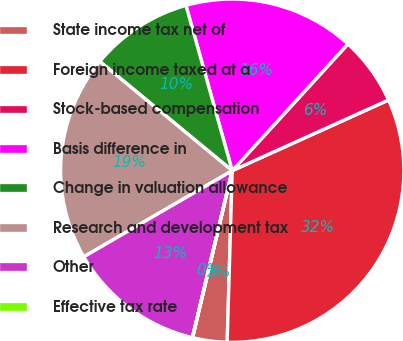Convert chart. <chart><loc_0><loc_0><loc_500><loc_500><pie_chart><fcel>State income tax net of<fcel>Foreign income taxed at a<fcel>Stock-based compensation<fcel>Basis difference in<fcel>Change in valuation allowance<fcel>Research and development tax<fcel>Other<fcel>Effective tax rate<nl><fcel>3.24%<fcel>32.22%<fcel>6.46%<fcel>16.12%<fcel>9.68%<fcel>19.34%<fcel>12.9%<fcel>0.02%<nl></chart> 